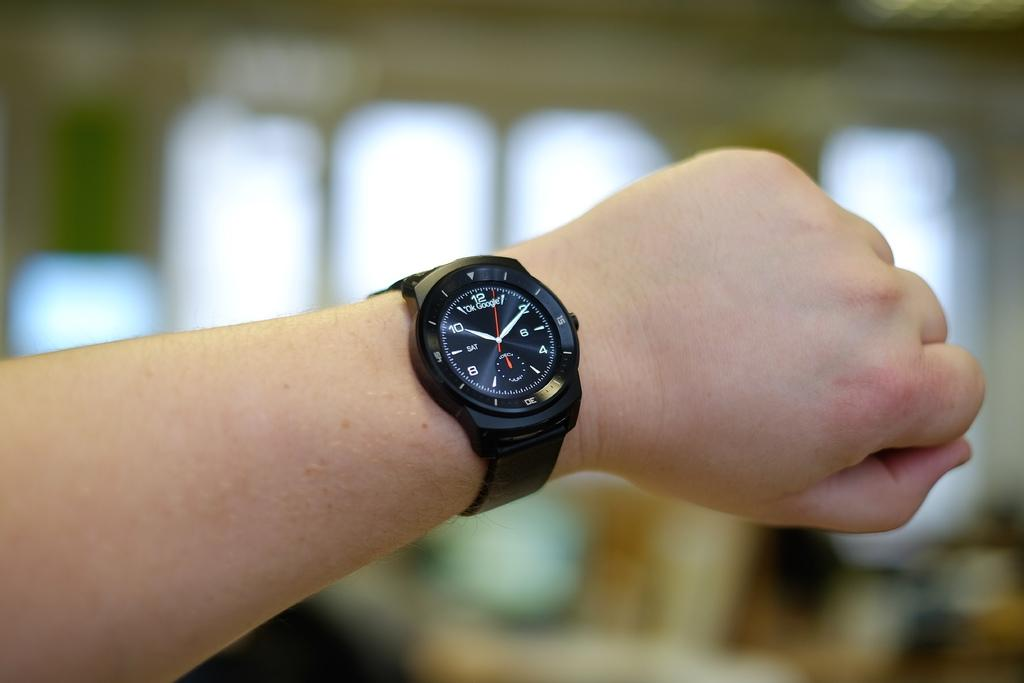What part of a person's body is visible in the image? There is a person's hand in the image. What is on the hand in the image? There is a watch on the hand. How would you describe the background of the image? The background of the image is blurred. Can you identify any objects in the background? Yes, there are objects visible in the background. What account number is written on the person's hand in the image? There is no account number written on the person's hand in the image. What point is the person's hand trying to make in the image? The image does not convey any specific point or message, so it is not possible to determine what the person's hand might be trying to convey. 